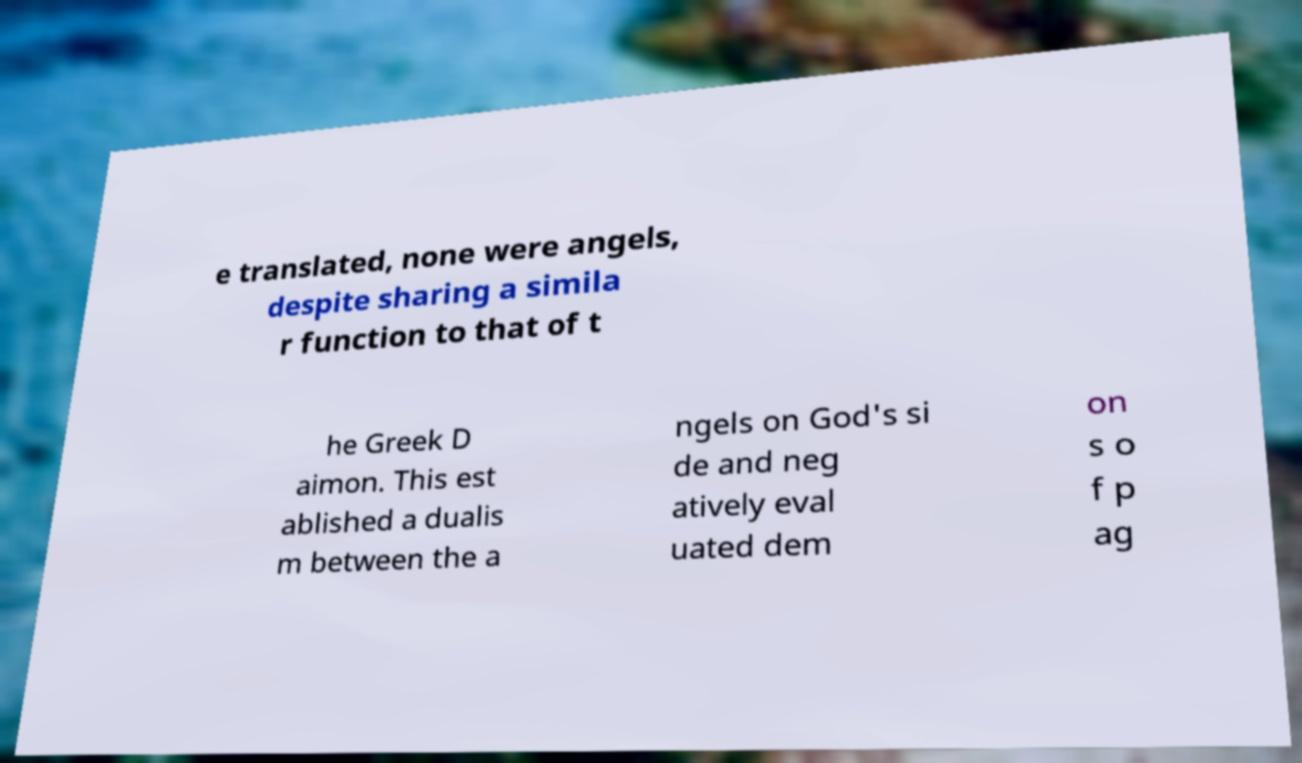For documentation purposes, I need the text within this image transcribed. Could you provide that? e translated, none were angels, despite sharing a simila r function to that of t he Greek D aimon. This est ablished a dualis m between the a ngels on God's si de and neg atively eval uated dem on s o f p ag 